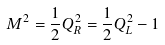<formula> <loc_0><loc_0><loc_500><loc_500>M ^ { 2 } = \frac { 1 } { 2 } Q _ { R } ^ { 2 } = \frac { 1 } { 2 } Q _ { L } ^ { 2 } - 1</formula> 